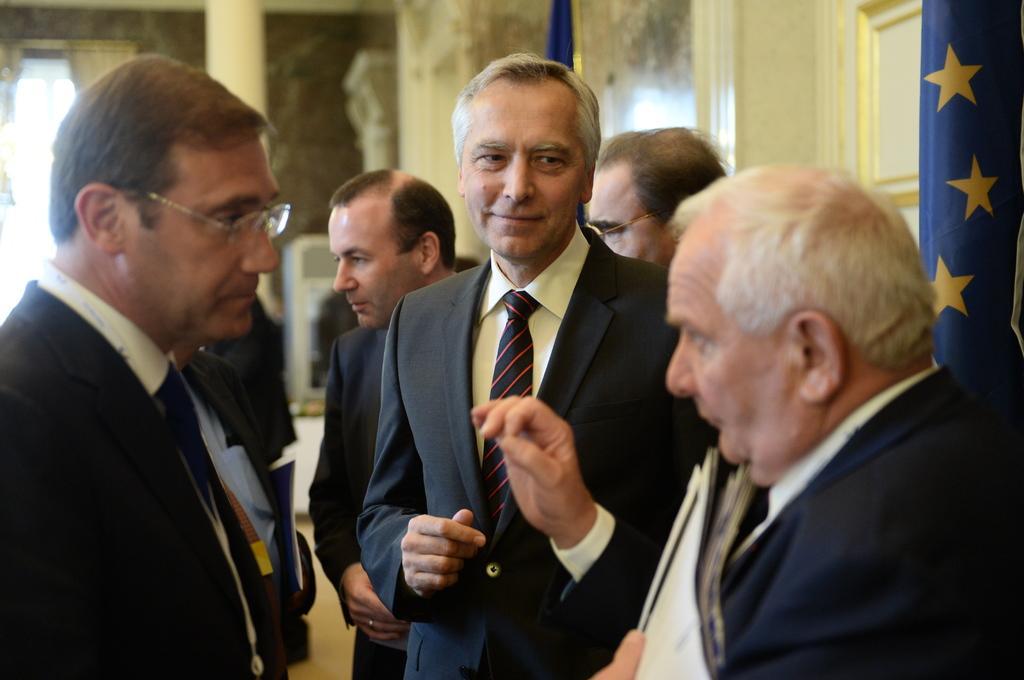Describe this image in one or two sentences. In the image there are a group of men standing in the foreground and on the right side there is a flag. The background of the men is blur. 